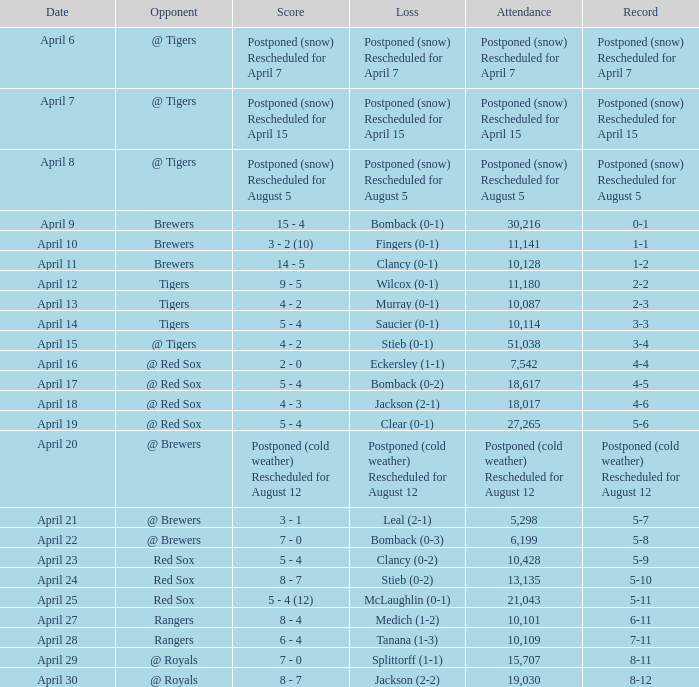What was the date for the game that had an attendance of 10,101? April 27. 